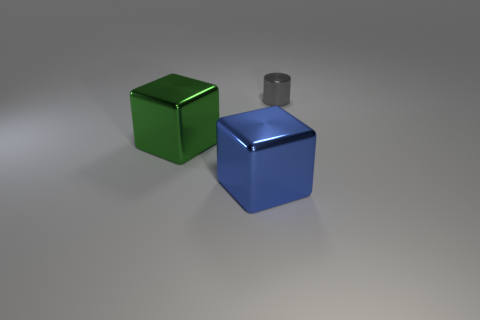Is there any other thing that has the same size as the gray cylinder?
Your answer should be compact. No. What number of objects are small gray metal objects or blue shiny cubes?
Give a very brief answer. 2. What size is the metal object that is on the left side of the blue metallic object?
Ensure brevity in your answer.  Large. There is a object that is to the right of the metal object that is in front of the green object; what number of green metal cubes are in front of it?
Your answer should be very brief. 1. What number of metal objects are to the left of the large blue metal block and behind the big green thing?
Provide a succinct answer. 0. What is the shape of the large thing that is in front of the green object?
Your answer should be very brief. Cube. Is the number of green things on the right side of the large green thing less than the number of gray metal objects that are in front of the small cylinder?
Your answer should be very brief. No. Does the big thing to the left of the large blue block have the same material as the big block in front of the green metal cube?
Offer a very short reply. Yes. What is the shape of the small thing?
Provide a short and direct response. Cylinder. Are there more large metallic cubes behind the gray shiny object than big green cubes that are in front of the green block?
Make the answer very short. No. 